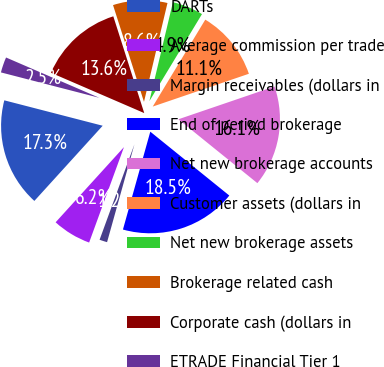Convert chart. <chart><loc_0><loc_0><loc_500><loc_500><pie_chart><fcel>DARTs<fcel>Average commission per trade<fcel>Margin receivables (dollars in<fcel>End of period brokerage<fcel>Net new brokerage accounts<fcel>Customer assets (dollars in<fcel>Net new brokerage assets<fcel>Brokerage related cash<fcel>Corporate cash (dollars in<fcel>ETRADE Financial Tier 1<nl><fcel>17.28%<fcel>6.17%<fcel>1.23%<fcel>18.52%<fcel>16.05%<fcel>11.11%<fcel>4.94%<fcel>8.64%<fcel>13.58%<fcel>2.47%<nl></chart> 